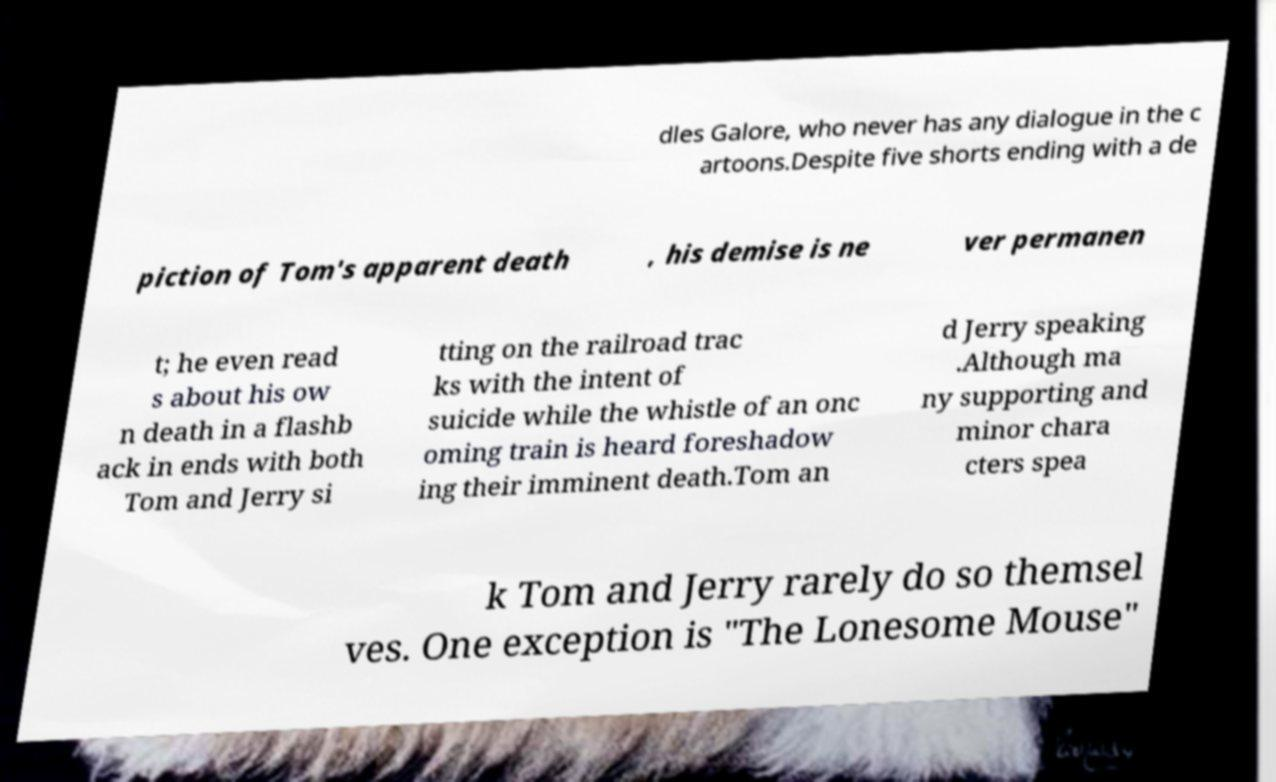What messages or text are displayed in this image? I need them in a readable, typed format. dles Galore, who never has any dialogue in the c artoons.Despite five shorts ending with a de piction of Tom's apparent death , his demise is ne ver permanen t; he even read s about his ow n death in a flashb ack in ends with both Tom and Jerry si tting on the railroad trac ks with the intent of suicide while the whistle of an onc oming train is heard foreshadow ing their imminent death.Tom an d Jerry speaking .Although ma ny supporting and minor chara cters spea k Tom and Jerry rarely do so themsel ves. One exception is "The Lonesome Mouse" 